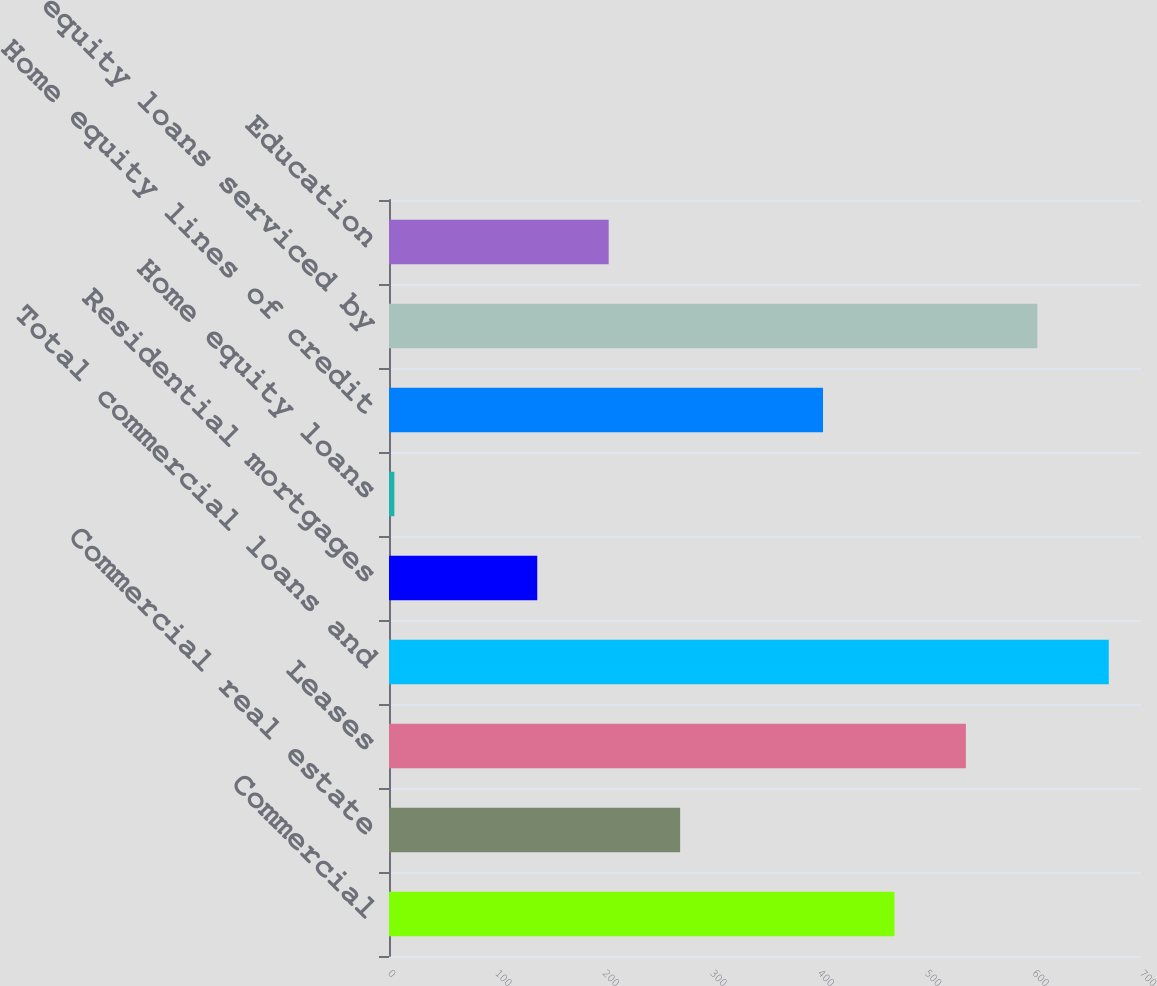Convert chart. <chart><loc_0><loc_0><loc_500><loc_500><bar_chart><fcel>Commercial<fcel>Commercial real estate<fcel>Leases<fcel>Total commercial loans and<fcel>Residential mortgages<fcel>Home equity loans<fcel>Home equity lines of credit<fcel>Home equity loans serviced by<fcel>Education<nl><fcel>470.5<fcel>271<fcel>537<fcel>670<fcel>138<fcel>5<fcel>404<fcel>603.5<fcel>204.5<nl></chart> 